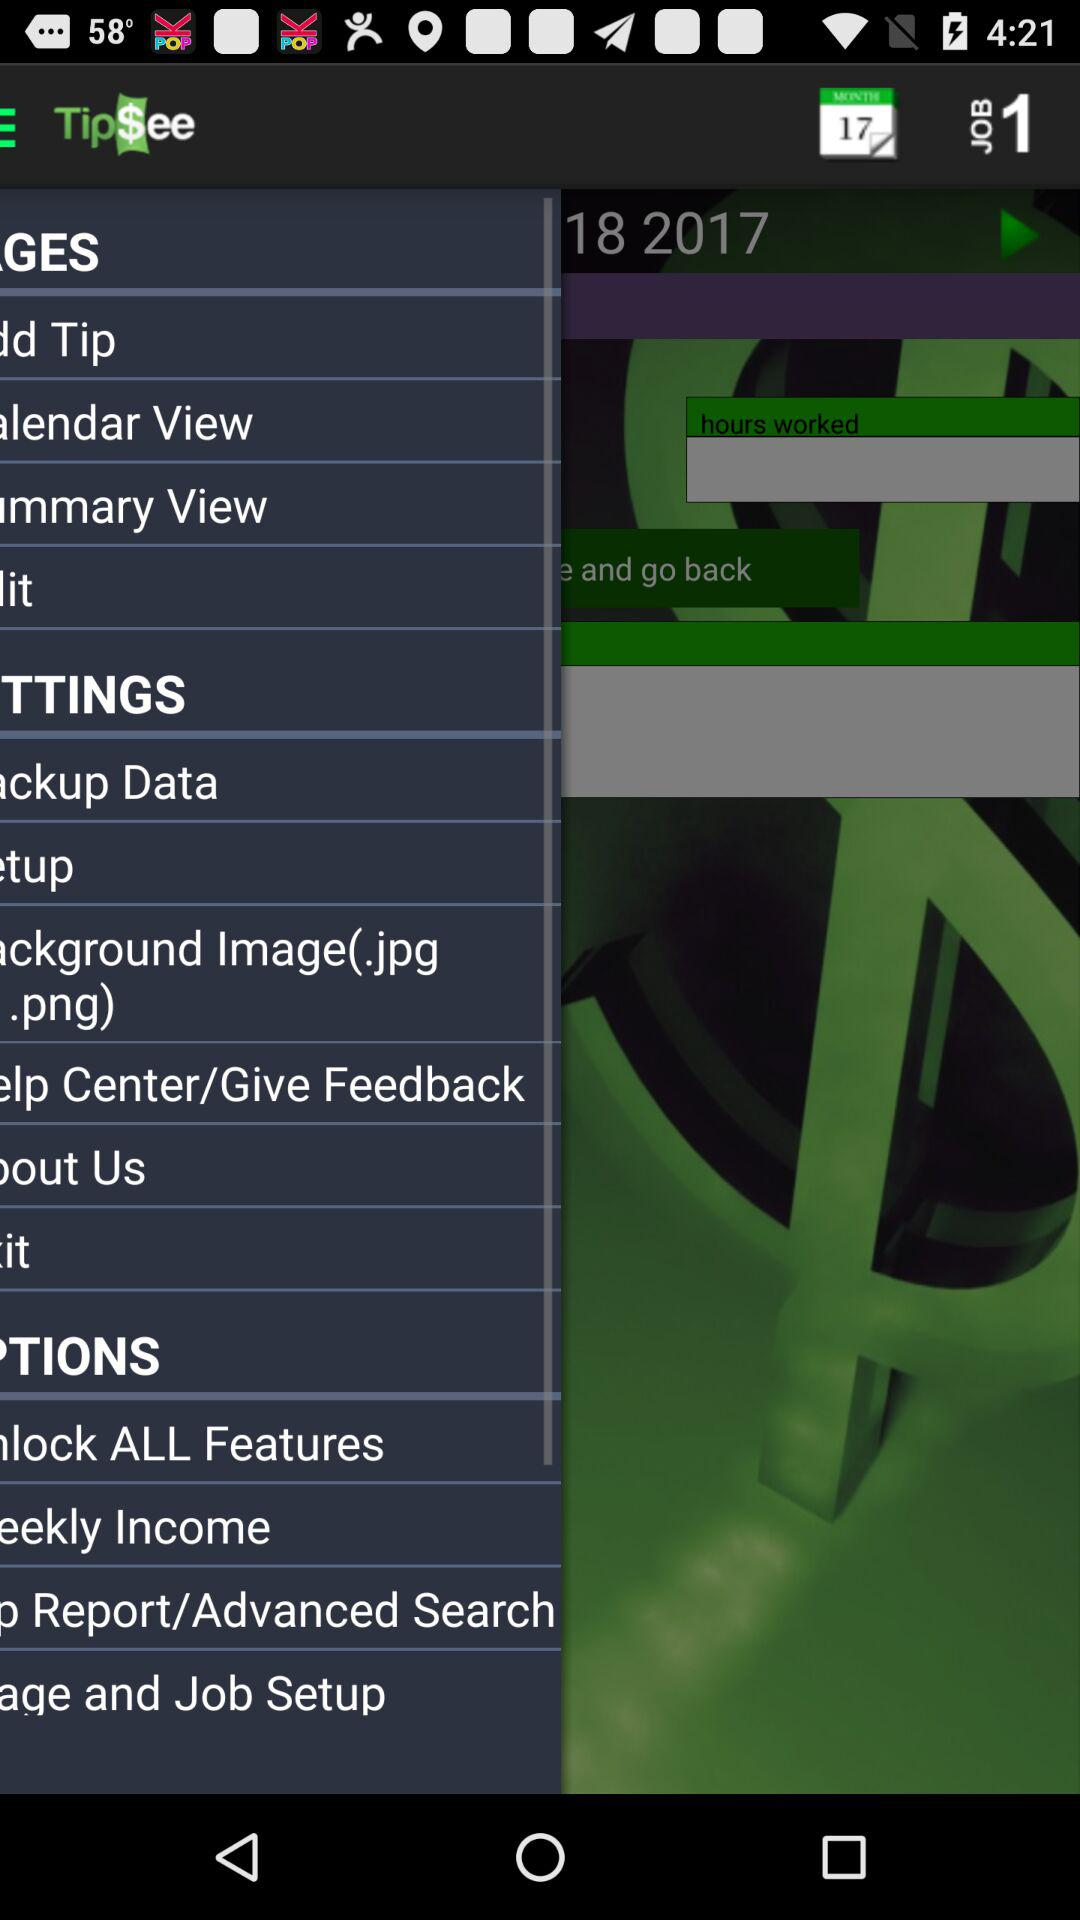What is the total amount of tips for the month of February?
Answer the question using a single word or phrase. $0.00 